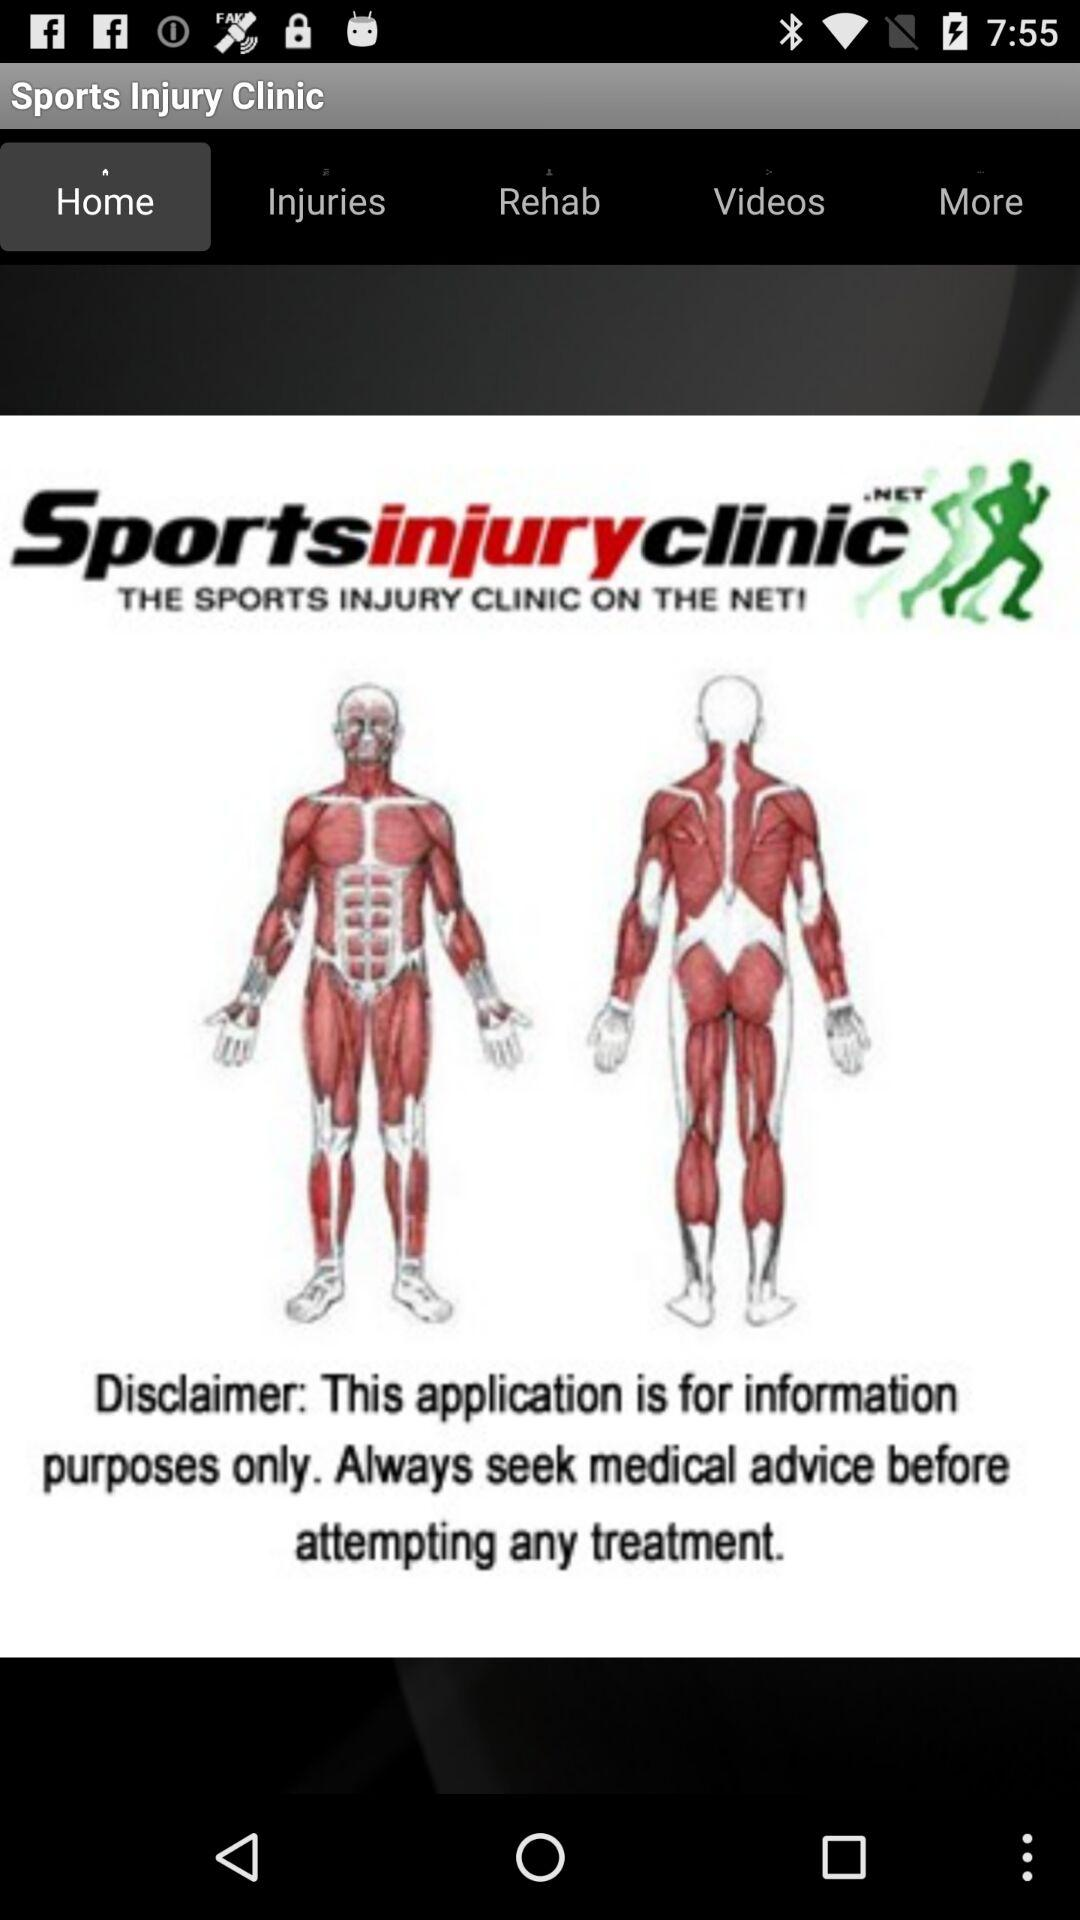What is the clinic name? The clinic name is "Sports Injury Clinic". 